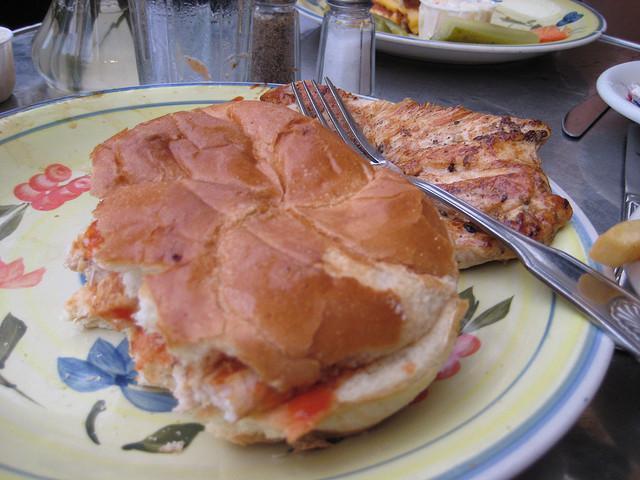How many cups are there?
Give a very brief answer. 1. How many sandwiches can you see?
Give a very brief answer. 1. How many men have a drink in their hand?
Give a very brief answer. 0. 